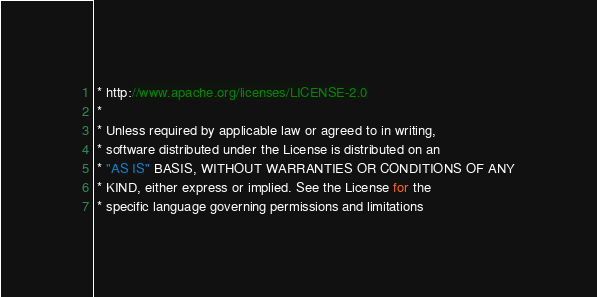<code> <loc_0><loc_0><loc_500><loc_500><_Java_> * http://www.apache.org/licenses/LICENSE-2.0
 *
 * Unless required by applicable law or agreed to in writing,
 * software distributed under the License is distributed on an
 * "AS IS" BASIS, WITHOUT WARRANTIES OR CONDITIONS OF ANY
 * KIND, either express or implied. See the License for the
 * specific language governing permissions and limitations</code> 